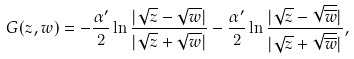<formula> <loc_0><loc_0><loc_500><loc_500>G ( z , w ) = - \frac { \alpha ^ { \prime } } { 2 } \ln \frac { | \sqrt { z } - \sqrt { w } | } { | \sqrt { z } + \sqrt { w } | } - \frac { \alpha ^ { \prime } } { 2 } \ln \frac { | \sqrt { z } - \sqrt { \overline { w } } | } { | \sqrt { z } + \sqrt { \overline { w } } | } ,</formula> 